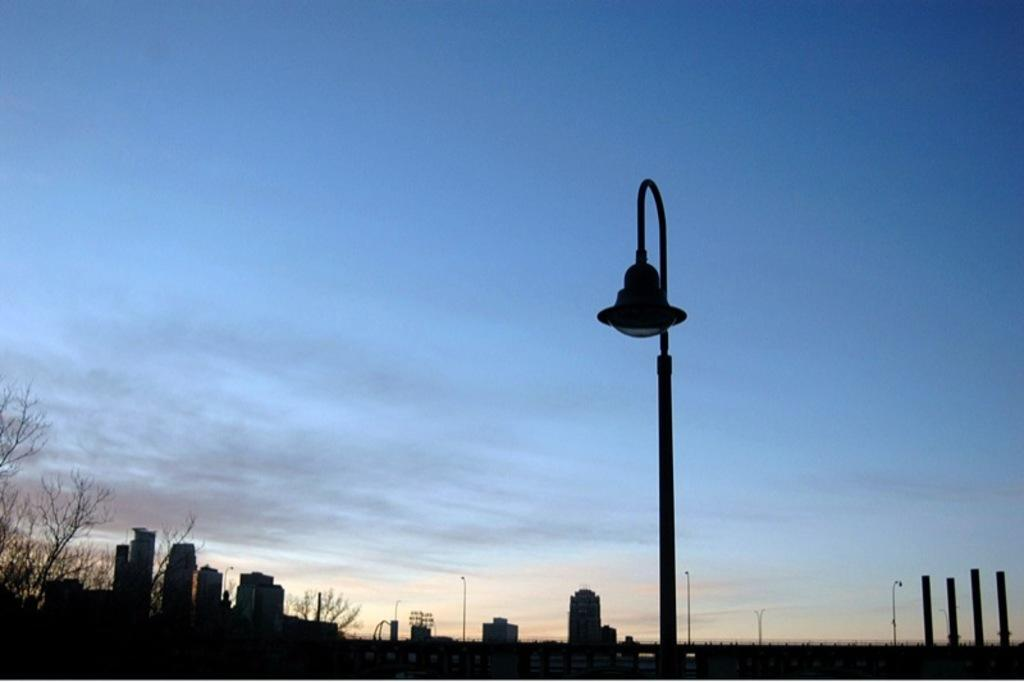What structure can be seen in the image that provides light? There is a light pole in the image. What type of man-made structures are visible in the image? There are buildings visible in the image. What type of vegetation is on the left side of the image? There are trees on the left side of the image. What else can be seen in the image that supports structures or objects? There are poles in the image. What is visible in the background of the image? The sky is visible in the image. What type of bait is being used to attract trucks in the image? There is no bait or trucks present in the image. How can we join the people in the image? There are no people present in the image, so we cannot join them. 